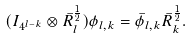<formula> <loc_0><loc_0><loc_500><loc_500>( I _ { 4 ^ { l - k } } \otimes \bar { R } _ { l } ^ { \frac { 1 } { 2 } } ) \phi _ { l , k } = \bar { \phi } _ { l , k } \bar { R } _ { k } ^ { \frac { 1 } { 2 } } .</formula> 